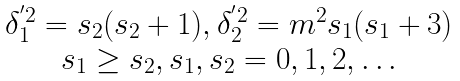Convert formula to latex. <formula><loc_0><loc_0><loc_500><loc_500>\begin{array} { c } \delta _ { 1 } ^ { ^ { \prime } 2 } = s _ { 2 } ( s _ { 2 } + 1 ) , \delta _ { 2 } ^ { ^ { \prime } 2 } = m ^ { 2 } s _ { 1 } ( s _ { 1 } + 3 ) \\ s _ { 1 } \geq s _ { 2 } , s _ { 1 } , s _ { 2 } = 0 , 1 , 2 , \dots \end{array}</formula> 